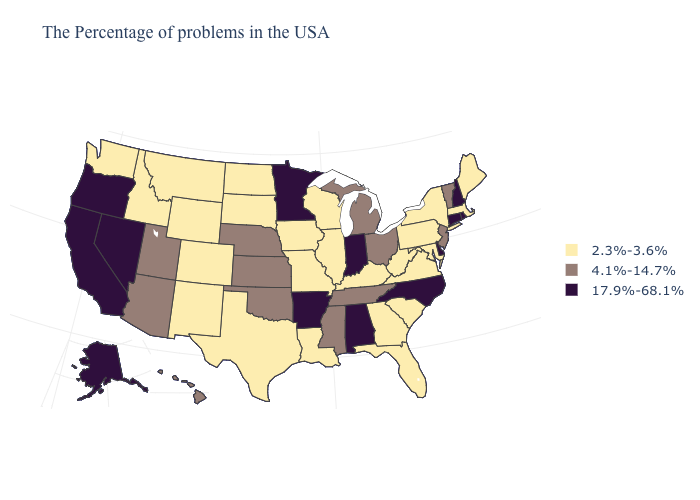Does the first symbol in the legend represent the smallest category?
Concise answer only. Yes. What is the value of Vermont?
Be succinct. 4.1%-14.7%. What is the lowest value in the USA?
Give a very brief answer. 2.3%-3.6%. Does Mississippi have a lower value than New Mexico?
Concise answer only. No. Which states hav the highest value in the West?
Answer briefly. Nevada, California, Oregon, Alaska. Name the states that have a value in the range 2.3%-3.6%?
Give a very brief answer. Maine, Massachusetts, New York, Maryland, Pennsylvania, Virginia, South Carolina, West Virginia, Florida, Georgia, Kentucky, Wisconsin, Illinois, Louisiana, Missouri, Iowa, Texas, South Dakota, North Dakota, Wyoming, Colorado, New Mexico, Montana, Idaho, Washington. What is the value of Illinois?
Write a very short answer. 2.3%-3.6%. Name the states that have a value in the range 2.3%-3.6%?
Quick response, please. Maine, Massachusetts, New York, Maryland, Pennsylvania, Virginia, South Carolina, West Virginia, Florida, Georgia, Kentucky, Wisconsin, Illinois, Louisiana, Missouri, Iowa, Texas, South Dakota, North Dakota, Wyoming, Colorado, New Mexico, Montana, Idaho, Washington. Name the states that have a value in the range 2.3%-3.6%?
Write a very short answer. Maine, Massachusetts, New York, Maryland, Pennsylvania, Virginia, South Carolina, West Virginia, Florida, Georgia, Kentucky, Wisconsin, Illinois, Louisiana, Missouri, Iowa, Texas, South Dakota, North Dakota, Wyoming, Colorado, New Mexico, Montana, Idaho, Washington. Does Idaho have the lowest value in the West?
Give a very brief answer. Yes. Name the states that have a value in the range 4.1%-14.7%?
Give a very brief answer. Vermont, New Jersey, Ohio, Michigan, Tennessee, Mississippi, Kansas, Nebraska, Oklahoma, Utah, Arizona, Hawaii. What is the value of Virginia?
Short answer required. 2.3%-3.6%. Which states have the highest value in the USA?
Give a very brief answer. Rhode Island, New Hampshire, Connecticut, Delaware, North Carolina, Indiana, Alabama, Arkansas, Minnesota, Nevada, California, Oregon, Alaska. Does the first symbol in the legend represent the smallest category?
Quick response, please. Yes. What is the value of Kentucky?
Concise answer only. 2.3%-3.6%. 